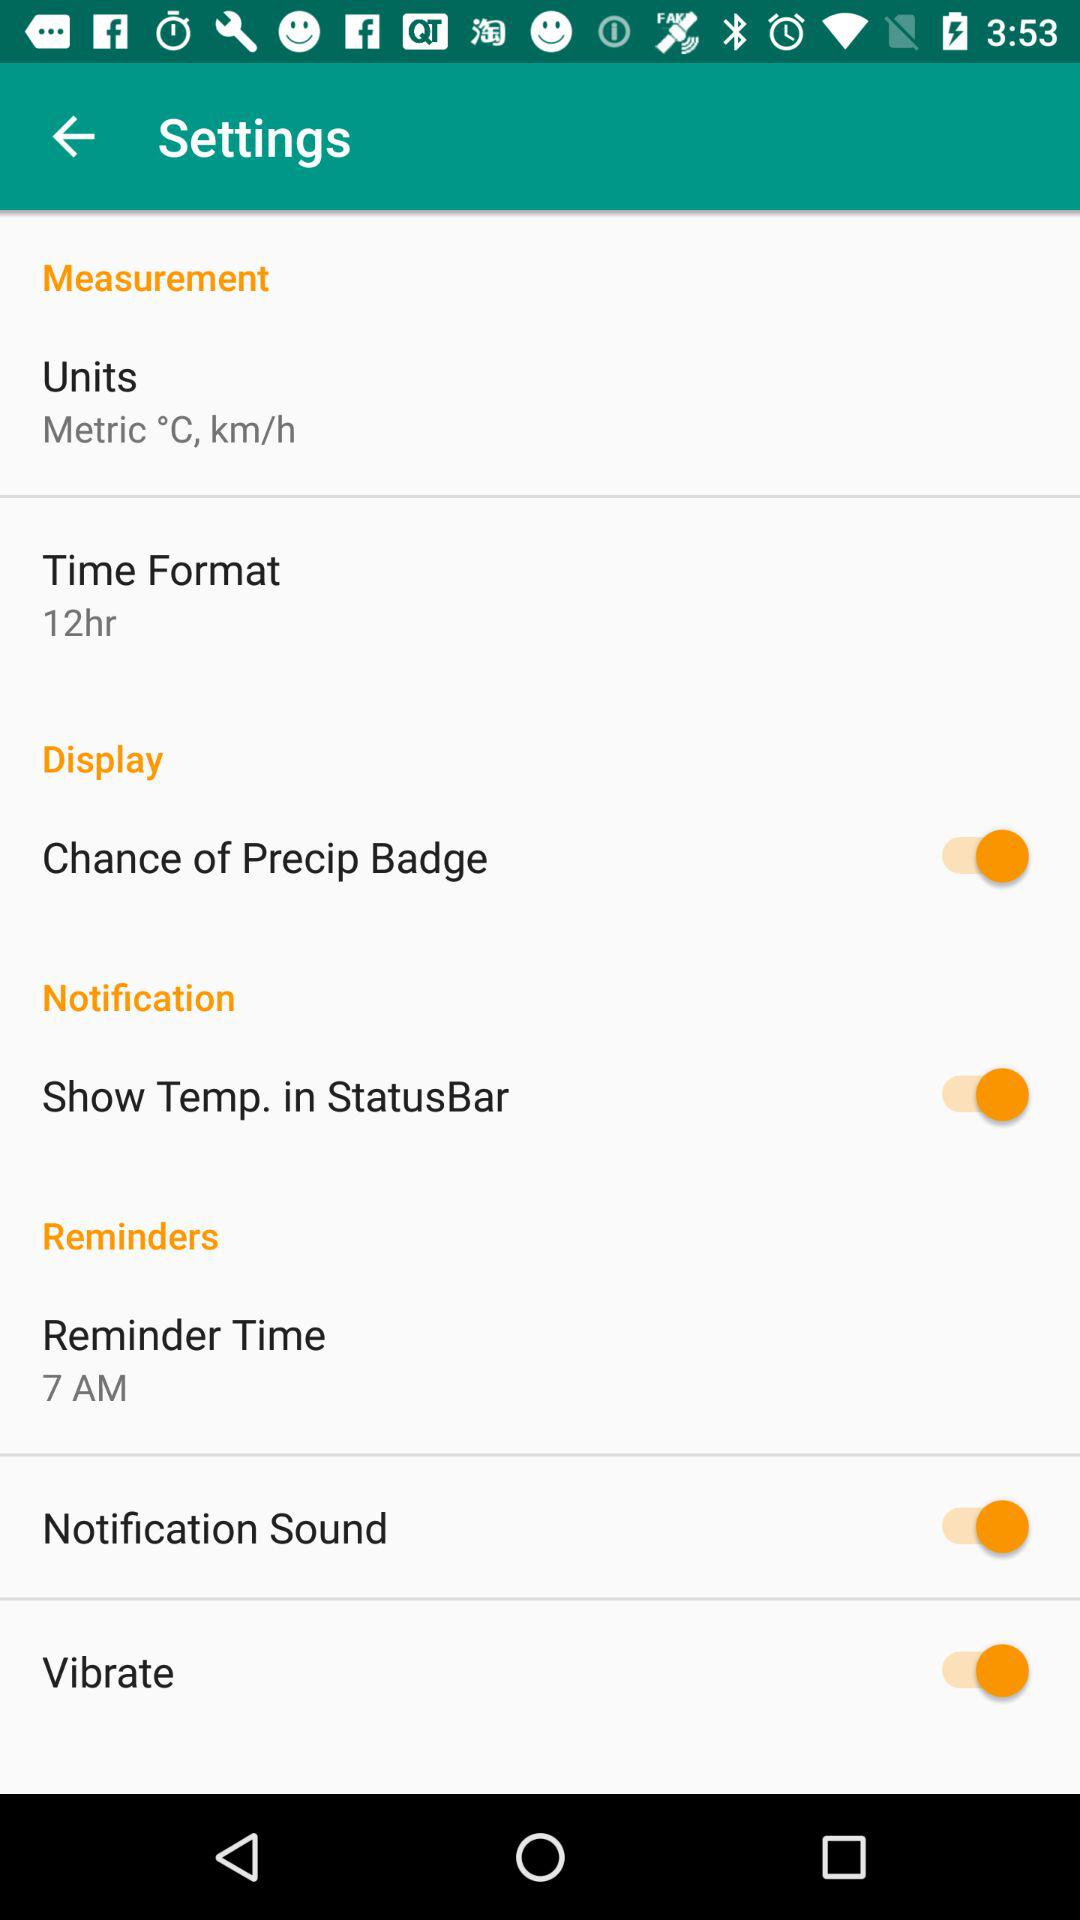How many items have a switch?
Answer the question using a single word or phrase. 4 